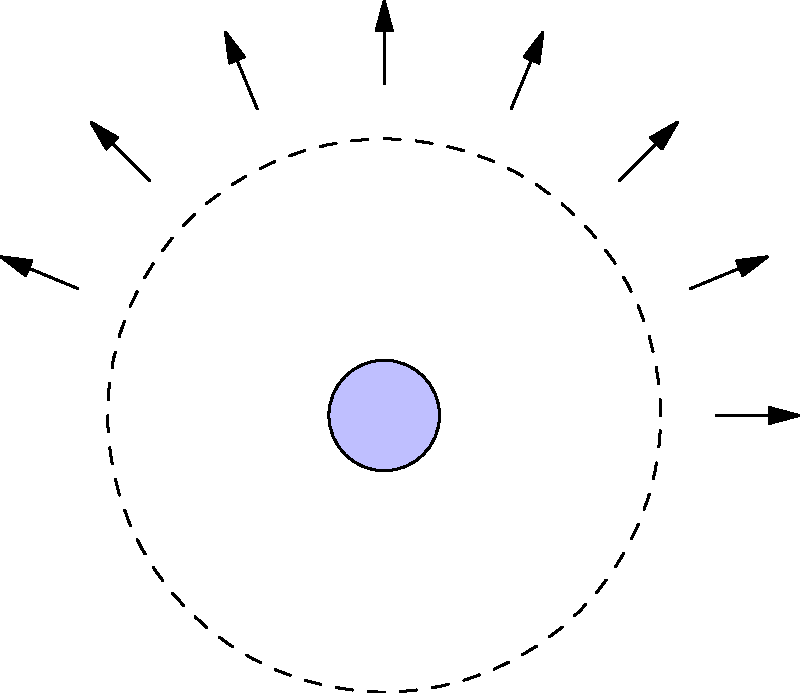Looking at the diagram of the Moon's phases, which phase would occur when the Moon is directly between the Earth and the Sun? Remember, even though bugs might be active at night, the Moon's phases aren't affected by them! Let's break this down step-by-step:

1. The diagram shows the Earth at the center and the Moon's orbit around it.

2. The Sun's rays are shown coming from the right side of the diagram.

3. The Moon's phases are depicted at various points in its orbit.

4. When the Moon is directly between the Earth and the Sun, it would be in the position on the far right of the diagram.

5. At this position, the side of the Moon facing the Earth is completely dark, as all the sunlight is hitting the far side of the Moon.

6. This phase, where we can't see any of the lit portion of the Moon from Earth, is called the New Moon.

7. In the diagram, the New Moon is labeled on the right side, confirming our reasoning.

Remember, during a New Moon, the night sky might seem darker, which could mean fewer bugs are active - a small comfort for those who don't like insects!
Answer: New Moon 